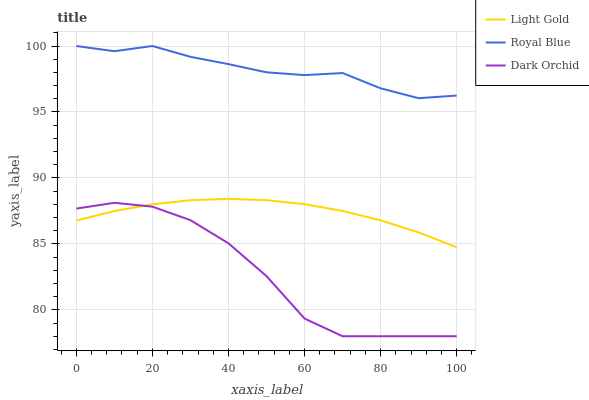Does Dark Orchid have the minimum area under the curve?
Answer yes or no. Yes. Does Royal Blue have the maximum area under the curve?
Answer yes or no. Yes. Does Light Gold have the minimum area under the curve?
Answer yes or no. No. Does Light Gold have the maximum area under the curve?
Answer yes or no. No. Is Light Gold the smoothest?
Answer yes or no. Yes. Is Dark Orchid the roughest?
Answer yes or no. Yes. Is Dark Orchid the smoothest?
Answer yes or no. No. Is Light Gold the roughest?
Answer yes or no. No. Does Dark Orchid have the lowest value?
Answer yes or no. Yes. Does Light Gold have the lowest value?
Answer yes or no. No. Does Royal Blue have the highest value?
Answer yes or no. Yes. Does Light Gold have the highest value?
Answer yes or no. No. Is Dark Orchid less than Royal Blue?
Answer yes or no. Yes. Is Royal Blue greater than Light Gold?
Answer yes or no. Yes. Does Light Gold intersect Dark Orchid?
Answer yes or no. Yes. Is Light Gold less than Dark Orchid?
Answer yes or no. No. Is Light Gold greater than Dark Orchid?
Answer yes or no. No. Does Dark Orchid intersect Royal Blue?
Answer yes or no. No. 